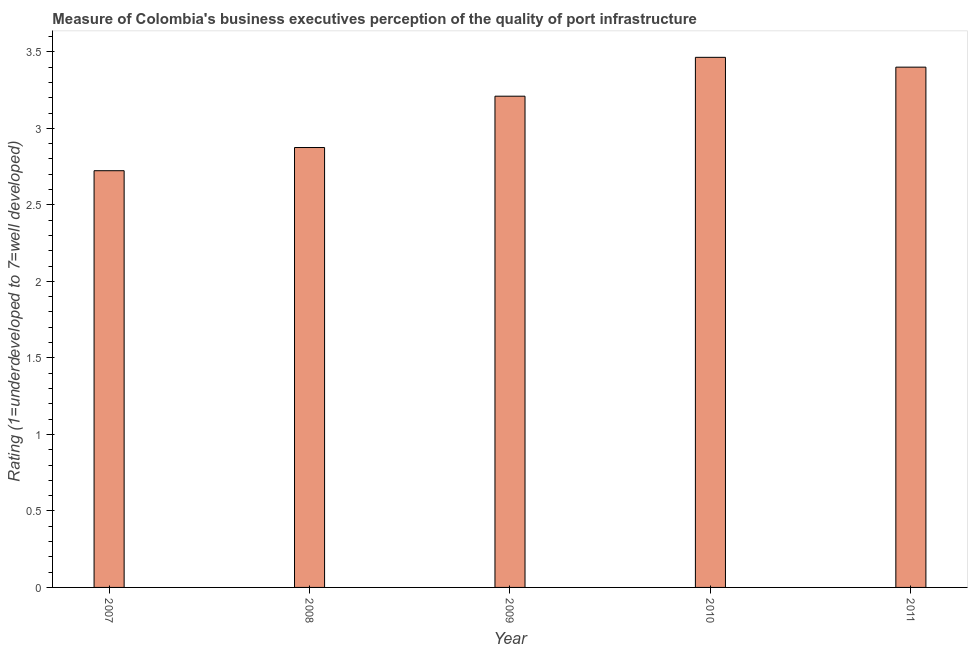What is the title of the graph?
Your response must be concise. Measure of Colombia's business executives perception of the quality of port infrastructure. What is the label or title of the X-axis?
Your answer should be very brief. Year. What is the label or title of the Y-axis?
Offer a very short reply. Rating (1=underdeveloped to 7=well developed) . What is the rating measuring quality of port infrastructure in 2007?
Provide a succinct answer. 2.72. Across all years, what is the maximum rating measuring quality of port infrastructure?
Your answer should be compact. 3.46. Across all years, what is the minimum rating measuring quality of port infrastructure?
Ensure brevity in your answer.  2.72. What is the sum of the rating measuring quality of port infrastructure?
Give a very brief answer. 15.67. What is the difference between the rating measuring quality of port infrastructure in 2009 and 2010?
Give a very brief answer. -0.25. What is the average rating measuring quality of port infrastructure per year?
Provide a short and direct response. 3.13. What is the median rating measuring quality of port infrastructure?
Your response must be concise. 3.21. What is the ratio of the rating measuring quality of port infrastructure in 2007 to that in 2008?
Keep it short and to the point. 0.95. Is the rating measuring quality of port infrastructure in 2010 less than that in 2011?
Offer a very short reply. No. What is the difference between the highest and the second highest rating measuring quality of port infrastructure?
Ensure brevity in your answer.  0.06. What is the difference between the highest and the lowest rating measuring quality of port infrastructure?
Keep it short and to the point. 0.74. In how many years, is the rating measuring quality of port infrastructure greater than the average rating measuring quality of port infrastructure taken over all years?
Offer a terse response. 3. Are all the bars in the graph horizontal?
Your answer should be compact. No. What is the difference between two consecutive major ticks on the Y-axis?
Provide a succinct answer. 0.5. What is the Rating (1=underdeveloped to 7=well developed)  in 2007?
Offer a terse response. 2.72. What is the Rating (1=underdeveloped to 7=well developed)  of 2008?
Offer a very short reply. 2.87. What is the Rating (1=underdeveloped to 7=well developed)  in 2009?
Offer a terse response. 3.21. What is the Rating (1=underdeveloped to 7=well developed)  of 2010?
Give a very brief answer. 3.46. What is the difference between the Rating (1=underdeveloped to 7=well developed)  in 2007 and 2008?
Keep it short and to the point. -0.15. What is the difference between the Rating (1=underdeveloped to 7=well developed)  in 2007 and 2009?
Provide a short and direct response. -0.49. What is the difference between the Rating (1=underdeveloped to 7=well developed)  in 2007 and 2010?
Offer a very short reply. -0.74. What is the difference between the Rating (1=underdeveloped to 7=well developed)  in 2007 and 2011?
Provide a short and direct response. -0.68. What is the difference between the Rating (1=underdeveloped to 7=well developed)  in 2008 and 2009?
Your response must be concise. -0.34. What is the difference between the Rating (1=underdeveloped to 7=well developed)  in 2008 and 2010?
Provide a short and direct response. -0.59. What is the difference between the Rating (1=underdeveloped to 7=well developed)  in 2008 and 2011?
Give a very brief answer. -0.53. What is the difference between the Rating (1=underdeveloped to 7=well developed)  in 2009 and 2010?
Provide a short and direct response. -0.25. What is the difference between the Rating (1=underdeveloped to 7=well developed)  in 2009 and 2011?
Ensure brevity in your answer.  -0.19. What is the difference between the Rating (1=underdeveloped to 7=well developed)  in 2010 and 2011?
Ensure brevity in your answer.  0.06. What is the ratio of the Rating (1=underdeveloped to 7=well developed)  in 2007 to that in 2008?
Make the answer very short. 0.95. What is the ratio of the Rating (1=underdeveloped to 7=well developed)  in 2007 to that in 2009?
Keep it short and to the point. 0.85. What is the ratio of the Rating (1=underdeveloped to 7=well developed)  in 2007 to that in 2010?
Your answer should be very brief. 0.79. What is the ratio of the Rating (1=underdeveloped to 7=well developed)  in 2007 to that in 2011?
Keep it short and to the point. 0.8. What is the ratio of the Rating (1=underdeveloped to 7=well developed)  in 2008 to that in 2009?
Offer a terse response. 0.9. What is the ratio of the Rating (1=underdeveloped to 7=well developed)  in 2008 to that in 2010?
Ensure brevity in your answer.  0.83. What is the ratio of the Rating (1=underdeveloped to 7=well developed)  in 2008 to that in 2011?
Keep it short and to the point. 0.85. What is the ratio of the Rating (1=underdeveloped to 7=well developed)  in 2009 to that in 2010?
Make the answer very short. 0.93. What is the ratio of the Rating (1=underdeveloped to 7=well developed)  in 2009 to that in 2011?
Provide a short and direct response. 0.94. What is the ratio of the Rating (1=underdeveloped to 7=well developed)  in 2010 to that in 2011?
Keep it short and to the point. 1.02. 